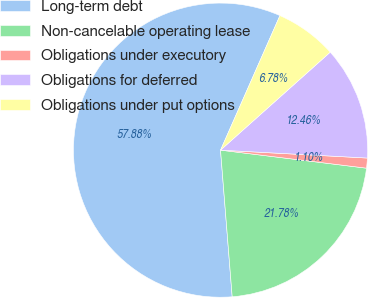Convert chart to OTSL. <chart><loc_0><loc_0><loc_500><loc_500><pie_chart><fcel>Long-term debt<fcel>Non-cancelable operating lease<fcel>Obligations under executory<fcel>Obligations for deferred<fcel>Obligations under put options<nl><fcel>57.88%<fcel>21.78%<fcel>1.1%<fcel>12.46%<fcel>6.78%<nl></chart> 